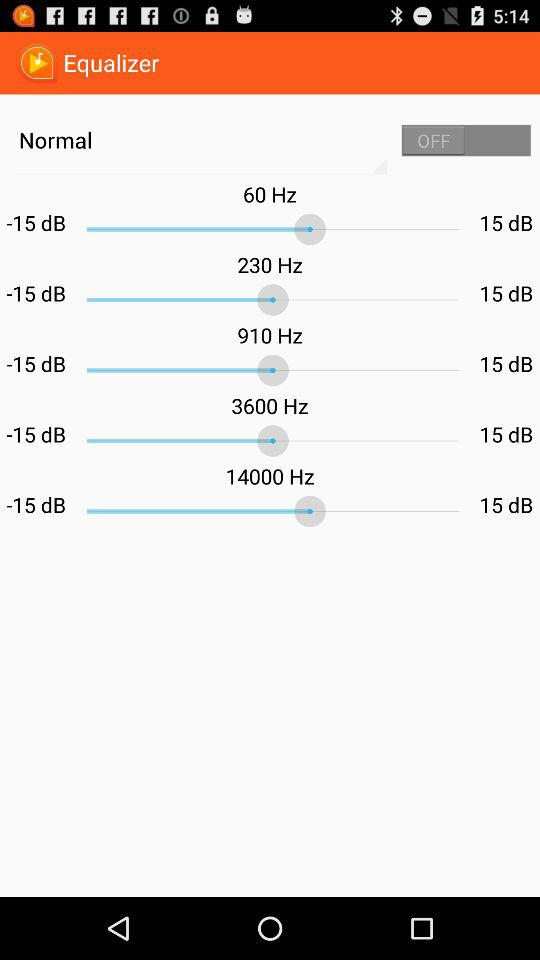What is the application name? The application name is "Equalizer". 